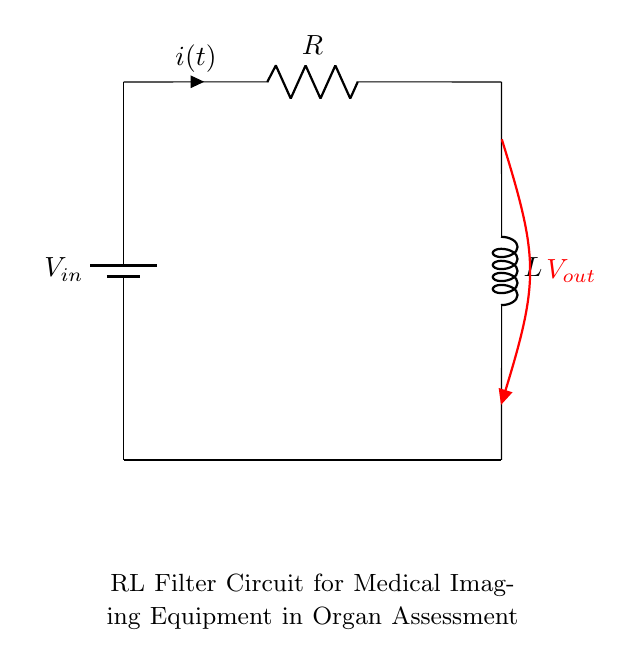What are the components of this circuit? The components are a resistor and an inductor connected in series with a voltage source.
Answer: Resistor and Inductor What is the function of the inductor in this filter circuit? The inductor stores energy in a magnetic field when current passes through it, which helps in filtering signals by allowing certain frequencies to pass while attenuating others.
Answer: Filtering signals What type of circuit is represented in the diagram? The circuit is a Resistor-Inductor filter circuit commonly used in medical imaging equipment.
Answer: Resistor-Inductor filter circuit What is the direction of the current in this circuit? The current flows from the positive terminal of the battery, through the resistor, and into the inductor, then to ground.
Answer: From battery to ground What does the output voltage depend on in this RL circuit? The output voltage depends on the current, resistor value, inductor value, and frequency of the input signal.
Answer: Current, resistance, inductance, frequency How does the inductor affect the phase of the output voltage? The inductor causes a phase shift between the input current and the output voltage, typically resulting in a lag in the output voltage relative to the input current.
Answer: Causes phase shift What is the purpose of the resistor in this circuit? The resistor limits the current flow in the circuit, ensuring safe operation and controlling the amount of power dissipated as heat.
Answer: Current limiting 